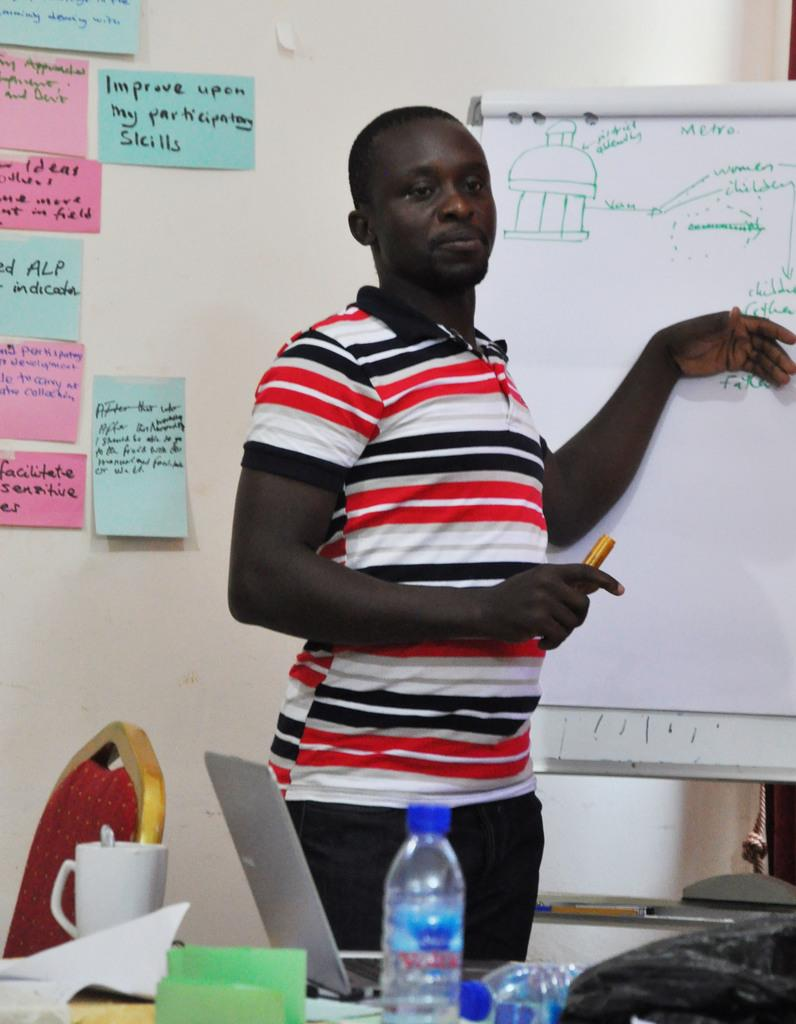<image>
Write a terse but informative summary of the picture. A man stands in front of a whiteboard next to some notes on the wall, one of which says Improve Upon My Participating Skills. 